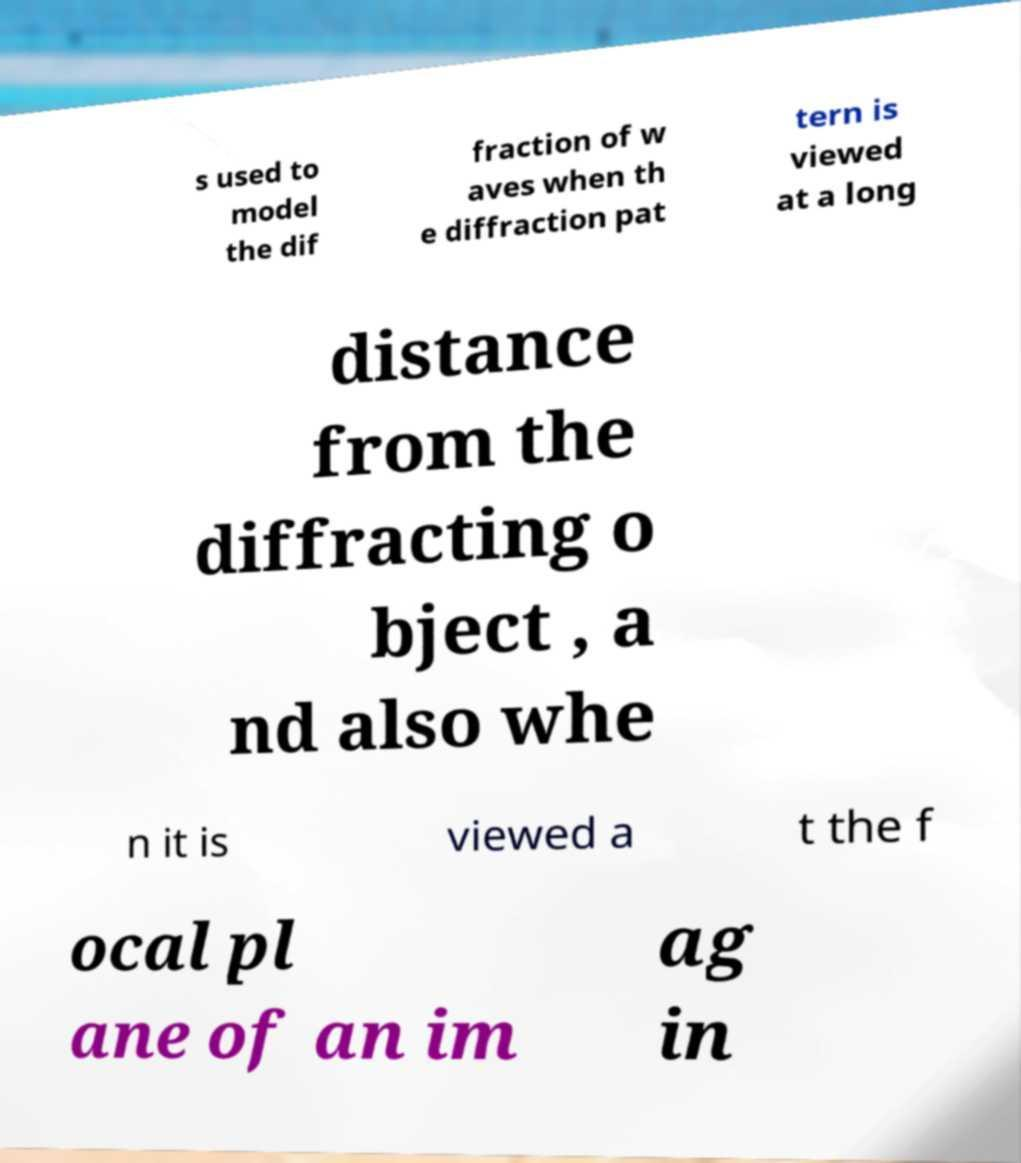What messages or text are displayed in this image? I need them in a readable, typed format. s used to model the dif fraction of w aves when th e diffraction pat tern is viewed at a long distance from the diffracting o bject , a nd also whe n it is viewed a t the f ocal pl ane of an im ag in 